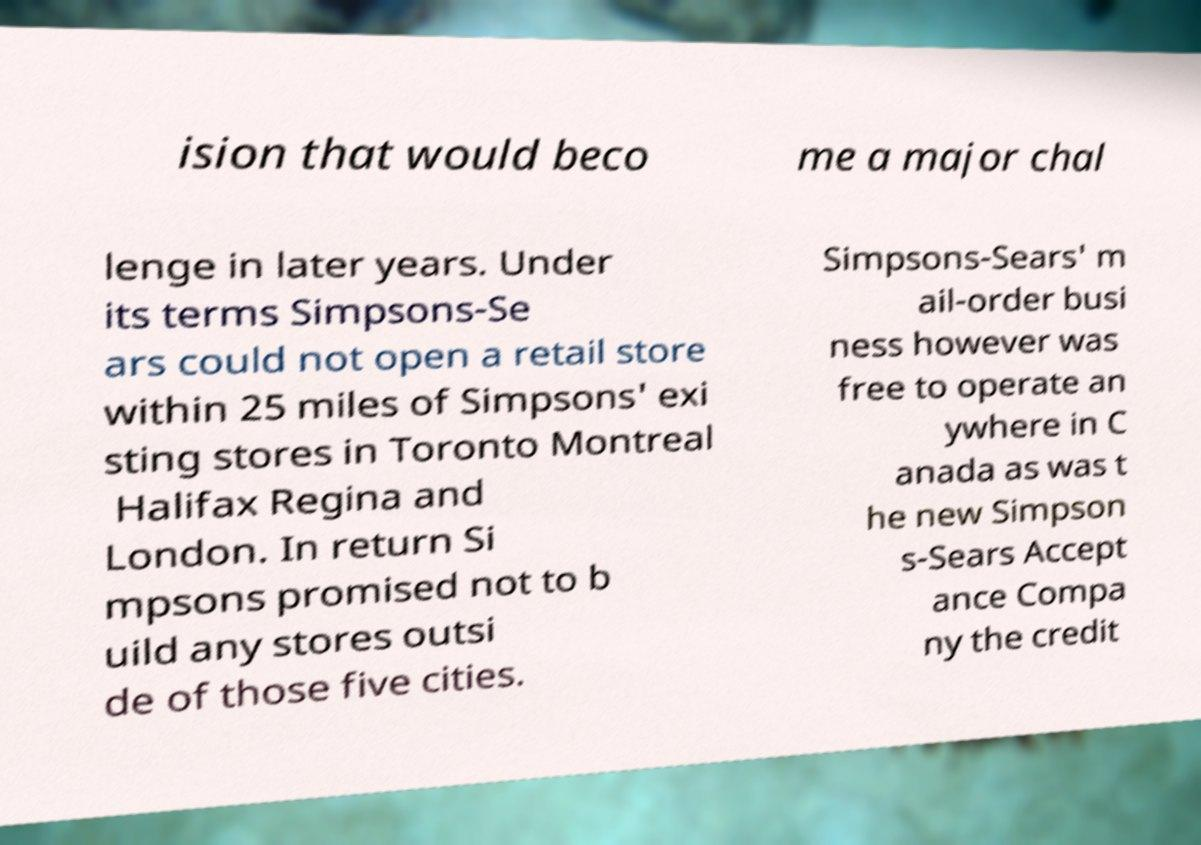Can you read and provide the text displayed in the image?This photo seems to have some interesting text. Can you extract and type it out for me? ision that would beco me a major chal lenge in later years. Under its terms Simpsons-Se ars could not open a retail store within 25 miles of Simpsons' exi sting stores in Toronto Montreal Halifax Regina and London. In return Si mpsons promised not to b uild any stores outsi de of those five cities. Simpsons-Sears' m ail-order busi ness however was free to operate an ywhere in C anada as was t he new Simpson s-Sears Accept ance Compa ny the credit 